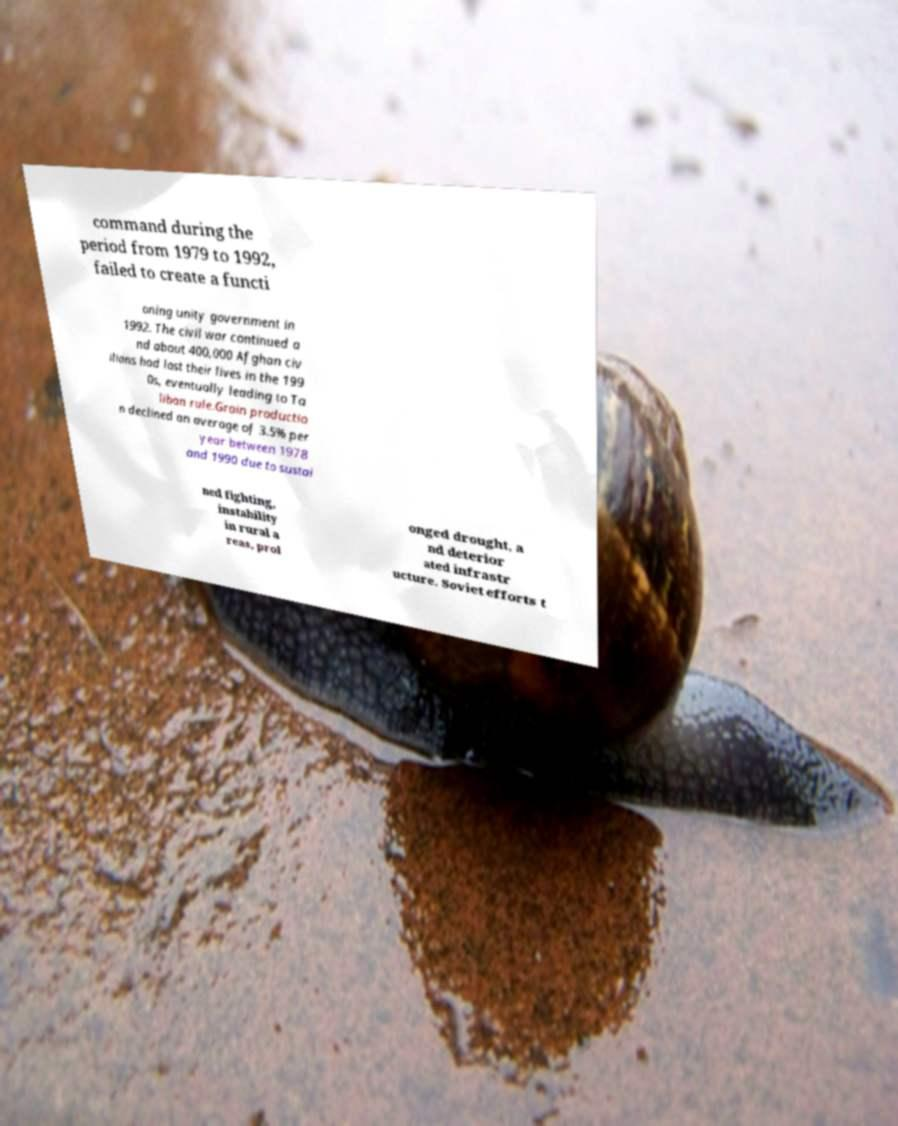There's text embedded in this image that I need extracted. Can you transcribe it verbatim? command during the period from 1979 to 1992, failed to create a functi oning unity government in 1992. The civil war continued a nd about 400,000 Afghan civ ilians had lost their lives in the 199 0s, eventually leading to Ta liban rule.Grain productio n declined an average of 3.5% per year between 1978 and 1990 due to sustai ned fighting, instability in rural a reas, prol onged drought, a nd deterior ated infrastr ucture. Soviet efforts t 